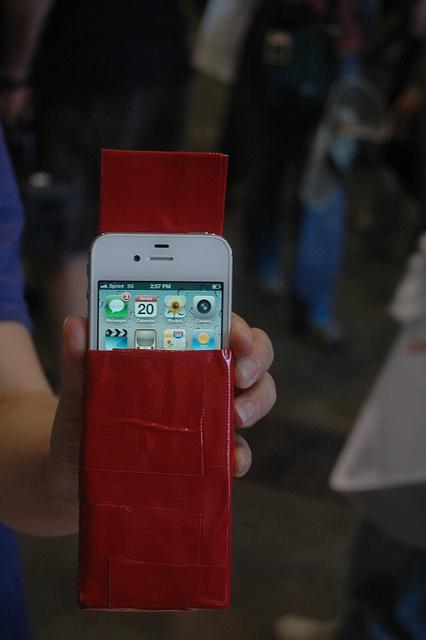How many cameras in the shot?
Write a very short answer. 1. How many new messages are there?
Be succinct. 1. What color is the phone case?
Quick response, please. Red. Is this a brand new phone?
Concise answer only. Yes. What numerical day of the month is it?
Concise answer only. 20. How many phones are there?
Write a very short answer. 1. What letter is on the cube head?
Short answer required. S. Is this phone an android?
Concise answer only. No. Is this a good camera?
Answer briefly. Yes. What is red?
Be succinct. Phone case. What type of phone is that?
Keep it brief. Iphone. What color is the floor?
Concise answer only. Brown. What color is the phone?
Concise answer only. White. Is the machine wrapped in plastic?
Answer briefly. No. 